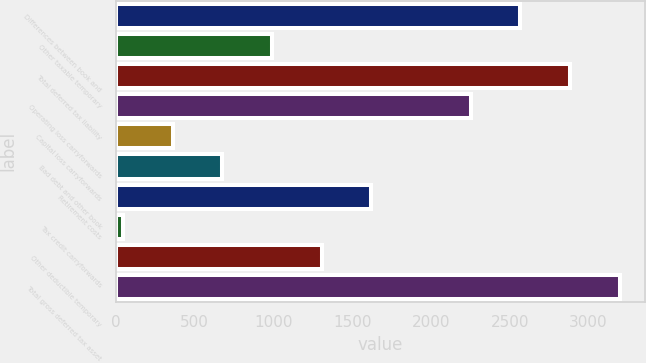<chart> <loc_0><loc_0><loc_500><loc_500><bar_chart><fcel>Differences between book and<fcel>Other taxable temporary<fcel>Total deferred tax liability<fcel>Operating loss carryforwards<fcel>Capital loss carryforwards<fcel>Bad debt and other book<fcel>Retirement costs<fcel>Tax credit carryforwards<fcel>Other deductible temporary<fcel>Total gross deferred tax asset<nl><fcel>2568.4<fcel>991.9<fcel>2883.7<fcel>2253.1<fcel>361.3<fcel>676.6<fcel>1622.5<fcel>46<fcel>1307.2<fcel>3199<nl></chart> 